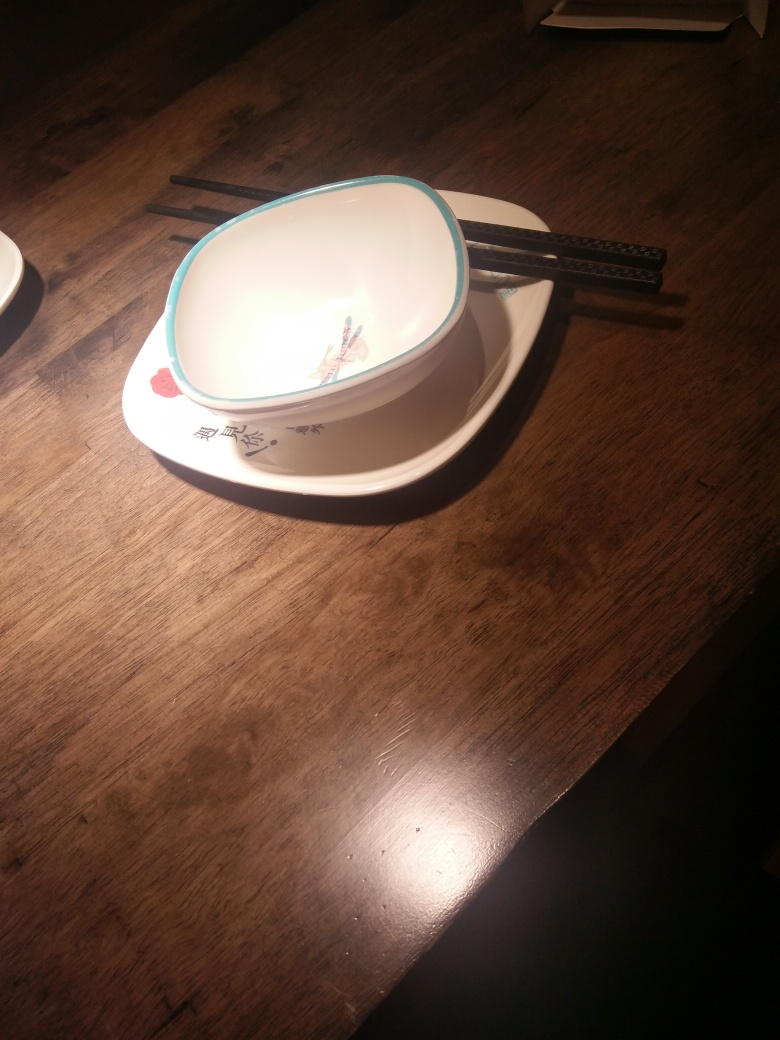Can you infer what meal might have been eaten with these utensils? Given the style of the chopsticks and the dish design, it is likely that an East Asian cuisine was served, which may include a variety of dishes such as sushi, noodles, or rice-based meals. 